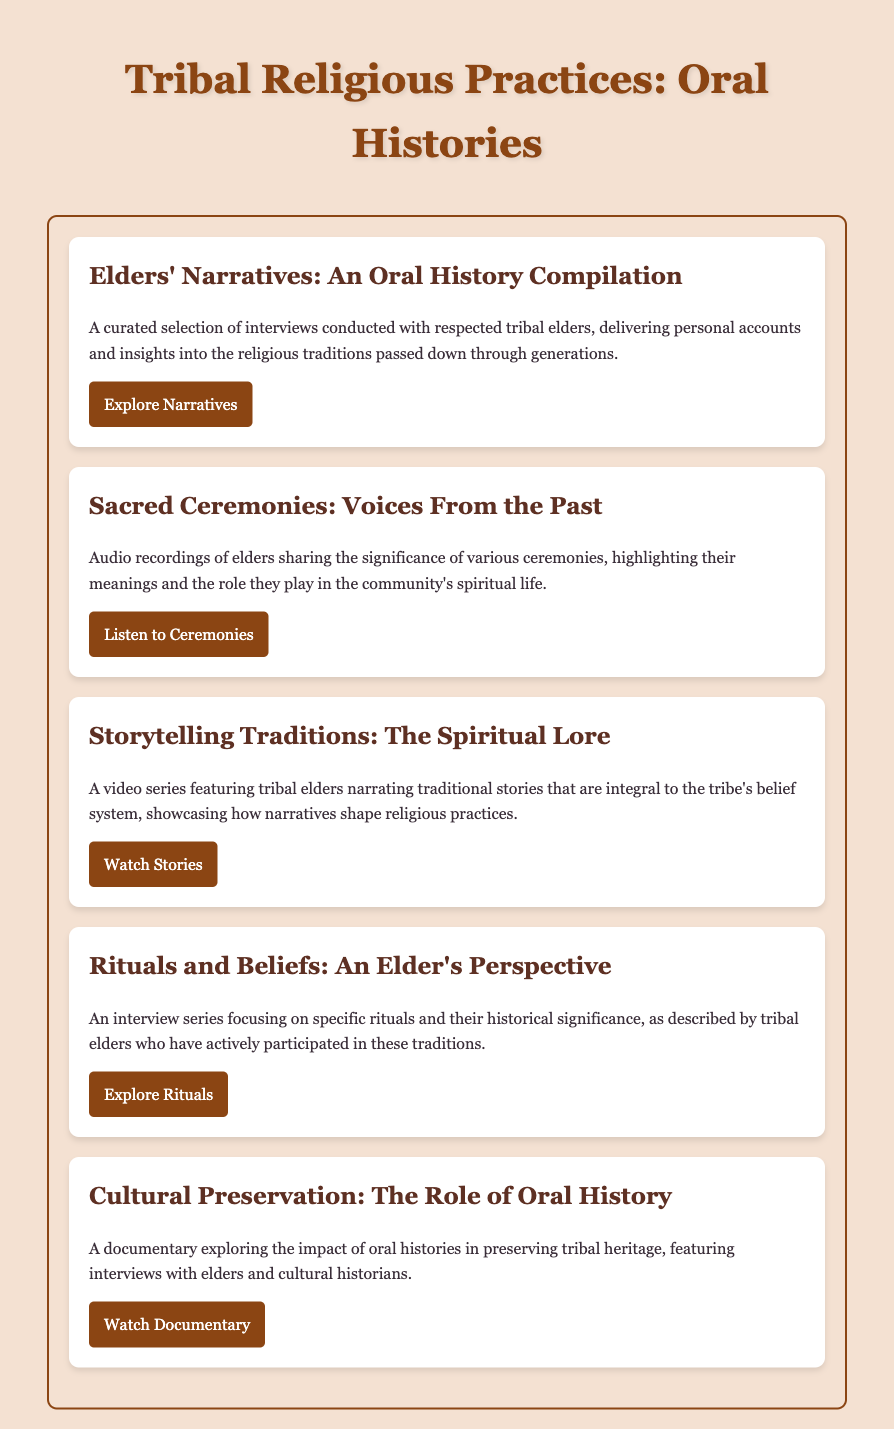What is the title of the document? The title is an important identifier found in the header of the document.
Answer: Tribal Religious Practices: Oral Histories How many main menu items are listed? Counting the distinct sections provides the total number of main menu items available in the document.
Answer: 5 What is the topic of the first menu item? The first menu item gives insight into its content related to oral histories, specifically regarding elders' narratives.
Answer: Elders' Narratives: An Oral History Compilation What type of media is associated with the storytelling traditions? The document specifies the format of storytelling traditions to provide context on how it is presented.
Answer: Video series What is the focus of the interview series mentioned in the fourth item? Understanding the focus of this specific series requires analyzing its description related to rituals and beliefs.
Answer: Specific rituals and their historical significance Which link leads to the audio recordings of elders? Identifying the correct link is essential to access specific audio recordings mentioned in the menu items.
Answer: https://example.com/sacred-ceremonies What does the documentary discuss? The documentary's description provides an understanding of its theme and scope regarding oral histories.
Answer: The impact of oral histories in preserving tribal heritage What color is the background of the document? Observing the overall design elements helps determine key visual features in the document's presentation.
Answer: Light beige 